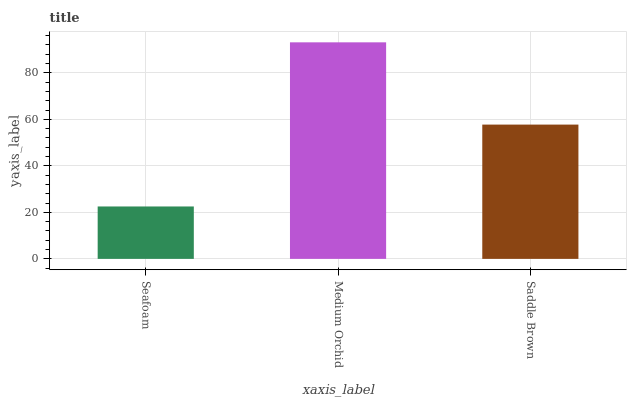Is Saddle Brown the minimum?
Answer yes or no. No. Is Saddle Brown the maximum?
Answer yes or no. No. Is Medium Orchid greater than Saddle Brown?
Answer yes or no. Yes. Is Saddle Brown less than Medium Orchid?
Answer yes or no. Yes. Is Saddle Brown greater than Medium Orchid?
Answer yes or no. No. Is Medium Orchid less than Saddle Brown?
Answer yes or no. No. Is Saddle Brown the high median?
Answer yes or no. Yes. Is Saddle Brown the low median?
Answer yes or no. Yes. Is Seafoam the high median?
Answer yes or no. No. Is Seafoam the low median?
Answer yes or no. No. 